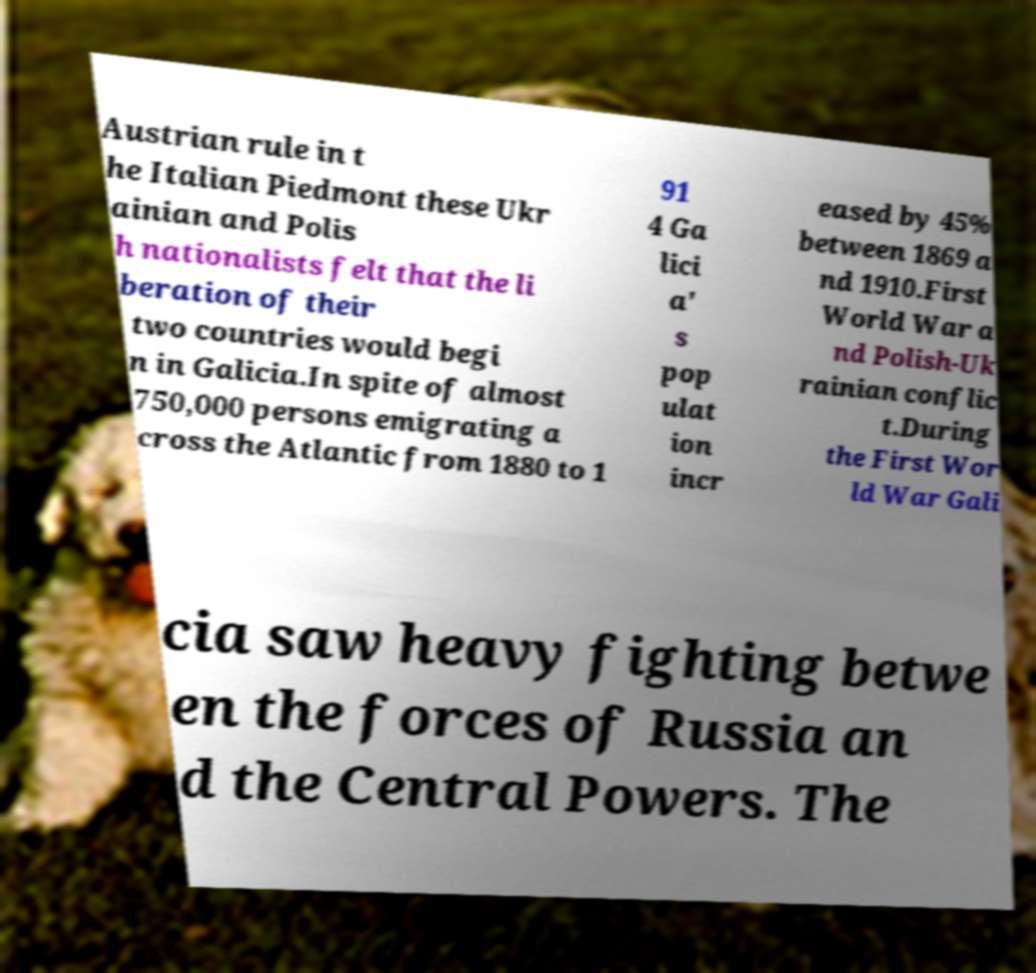Could you extract and type out the text from this image? Austrian rule in t he Italian Piedmont these Ukr ainian and Polis h nationalists felt that the li beration of their two countries would begi n in Galicia.In spite of almost 750,000 persons emigrating a cross the Atlantic from 1880 to 1 91 4 Ga lici a' s pop ulat ion incr eased by 45% between 1869 a nd 1910.First World War a nd Polish-Uk rainian conflic t.During the First Wor ld War Gali cia saw heavy fighting betwe en the forces of Russia an d the Central Powers. The 